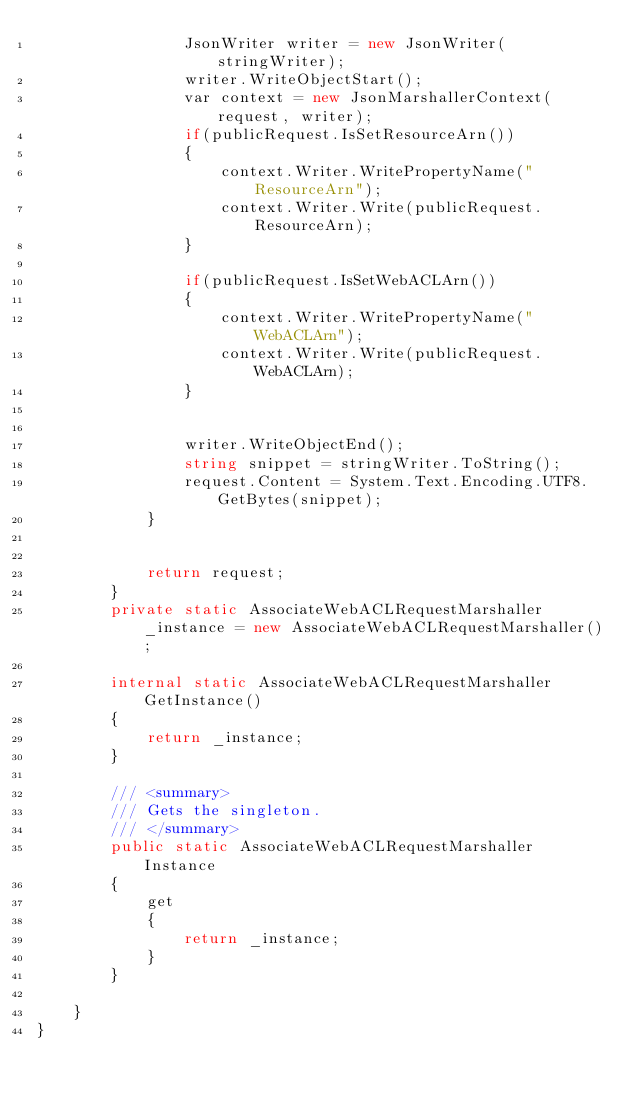Convert code to text. <code><loc_0><loc_0><loc_500><loc_500><_C#_>                JsonWriter writer = new JsonWriter(stringWriter);
                writer.WriteObjectStart();
                var context = new JsonMarshallerContext(request, writer);
                if(publicRequest.IsSetResourceArn())
                {
                    context.Writer.WritePropertyName("ResourceArn");
                    context.Writer.Write(publicRequest.ResourceArn);
                }

                if(publicRequest.IsSetWebACLArn())
                {
                    context.Writer.WritePropertyName("WebACLArn");
                    context.Writer.Write(publicRequest.WebACLArn);
                }

        
                writer.WriteObjectEnd();
                string snippet = stringWriter.ToString();
                request.Content = System.Text.Encoding.UTF8.GetBytes(snippet);
            }


            return request;
        }
        private static AssociateWebACLRequestMarshaller _instance = new AssociateWebACLRequestMarshaller();        

        internal static AssociateWebACLRequestMarshaller GetInstance()
        {
            return _instance;
        }

        /// <summary>
        /// Gets the singleton.
        /// </summary>  
        public static AssociateWebACLRequestMarshaller Instance
        {
            get
            {
                return _instance;
            }
        }

    }
}</code> 